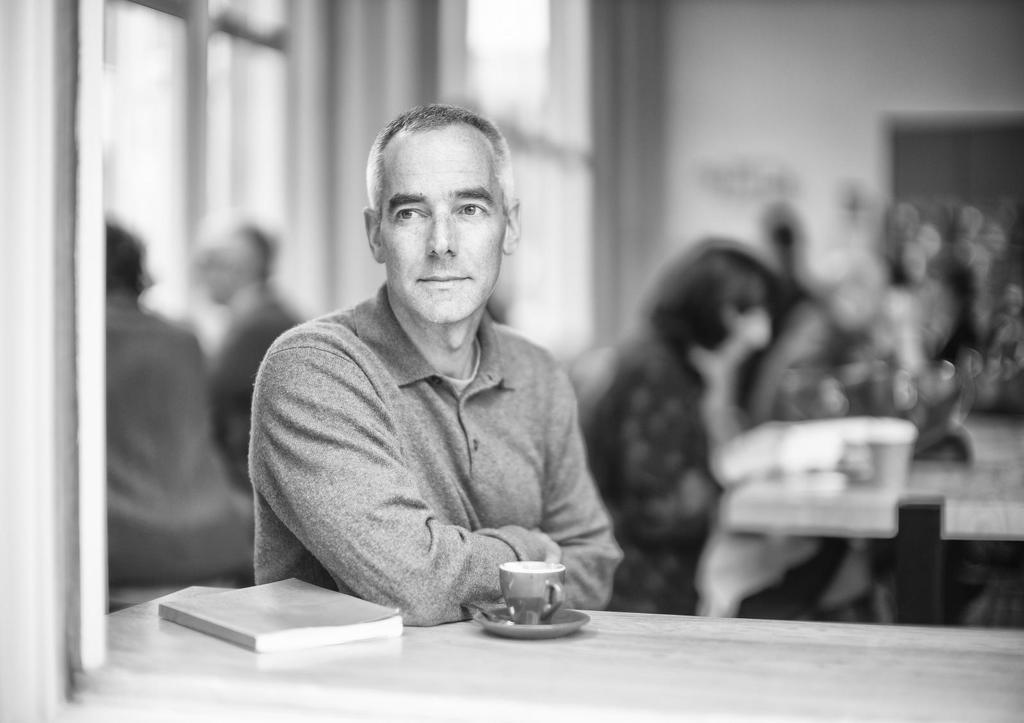Can you describe this image briefly? In the image in the center we can see one person standing and smiling,which we can see on his face. In front of him,there is a table. On the table,we can see one book,cup and saucer. In the background there is a wall,door,table and few people were sitting. 